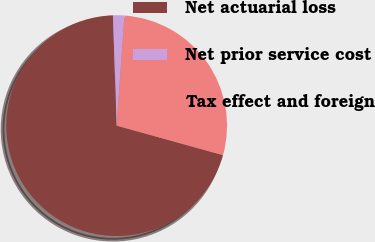Convert chart. <chart><loc_0><loc_0><loc_500><loc_500><pie_chart><fcel>Net actuarial loss<fcel>Net prior service cost<fcel>Tax effect and foreign<nl><fcel>70.16%<fcel>1.67%<fcel>28.17%<nl></chart> 